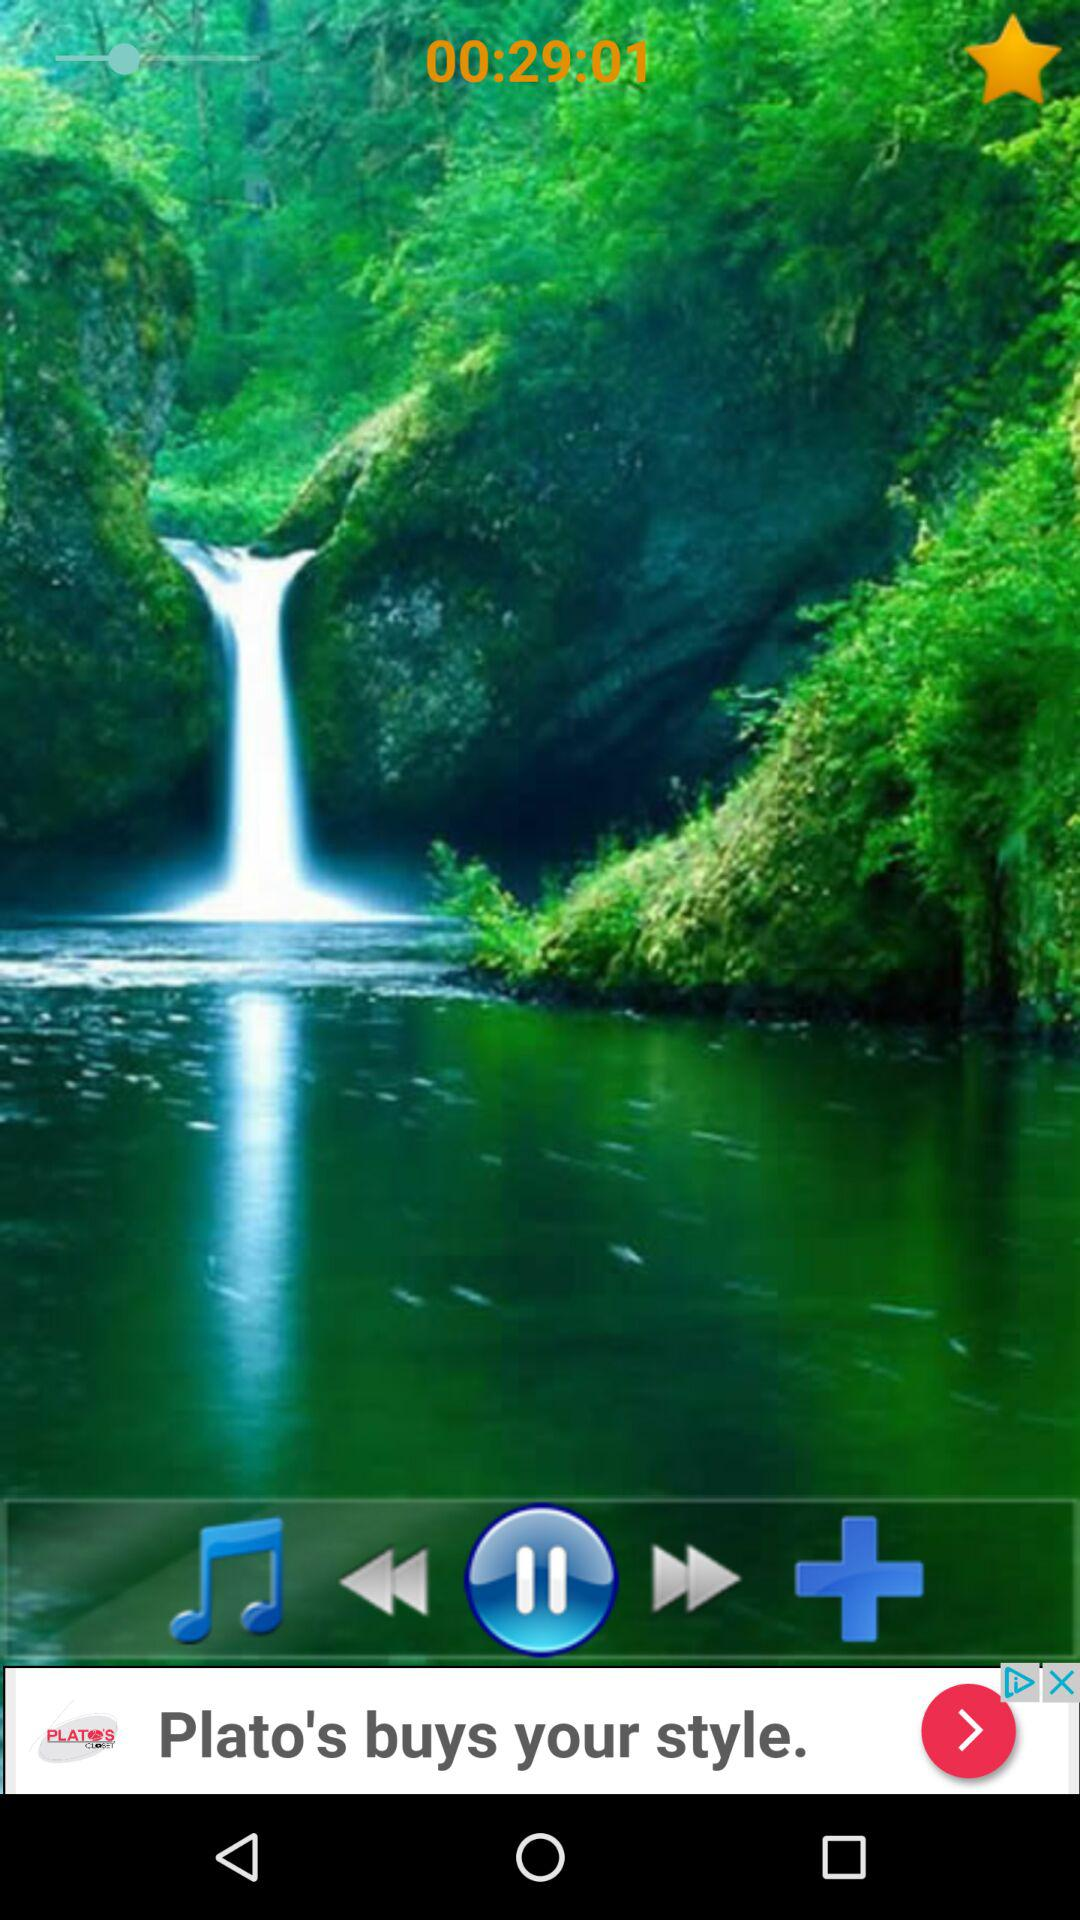What is the duration of video? The duration of the video is 29 minutes and 1 second. 